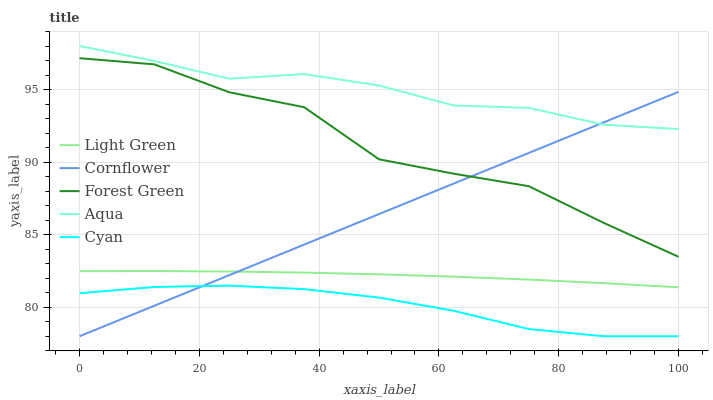Does Cyan have the minimum area under the curve?
Answer yes or no. Yes. Does Aqua have the maximum area under the curve?
Answer yes or no. Yes. Does Forest Green have the minimum area under the curve?
Answer yes or no. No. Does Forest Green have the maximum area under the curve?
Answer yes or no. No. Is Cornflower the smoothest?
Answer yes or no. Yes. Is Forest Green the roughest?
Answer yes or no. Yes. Is Aqua the smoothest?
Answer yes or no. No. Is Aqua the roughest?
Answer yes or no. No. Does Cornflower have the lowest value?
Answer yes or no. Yes. Does Forest Green have the lowest value?
Answer yes or no. No. Does Aqua have the highest value?
Answer yes or no. Yes. Does Forest Green have the highest value?
Answer yes or no. No. Is Light Green less than Forest Green?
Answer yes or no. Yes. Is Light Green greater than Cyan?
Answer yes or no. Yes. Does Cornflower intersect Light Green?
Answer yes or no. Yes. Is Cornflower less than Light Green?
Answer yes or no. No. Is Cornflower greater than Light Green?
Answer yes or no. No. Does Light Green intersect Forest Green?
Answer yes or no. No. 